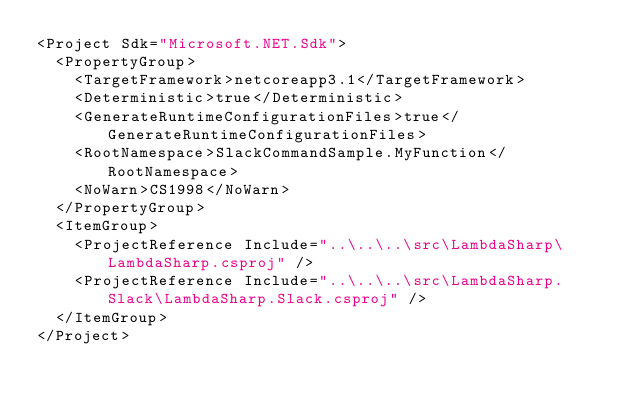Convert code to text. <code><loc_0><loc_0><loc_500><loc_500><_XML_><Project Sdk="Microsoft.NET.Sdk">
  <PropertyGroup>
    <TargetFramework>netcoreapp3.1</TargetFramework>
    <Deterministic>true</Deterministic>
    <GenerateRuntimeConfigurationFiles>true</GenerateRuntimeConfigurationFiles>
    <RootNamespace>SlackCommandSample.MyFunction</RootNamespace>
    <NoWarn>CS1998</NoWarn>
  </PropertyGroup>
  <ItemGroup>
    <ProjectReference Include="..\..\..\src\LambdaSharp\LambdaSharp.csproj" />
    <ProjectReference Include="..\..\..\src\LambdaSharp.Slack\LambdaSharp.Slack.csproj" />
  </ItemGroup>
</Project></code> 